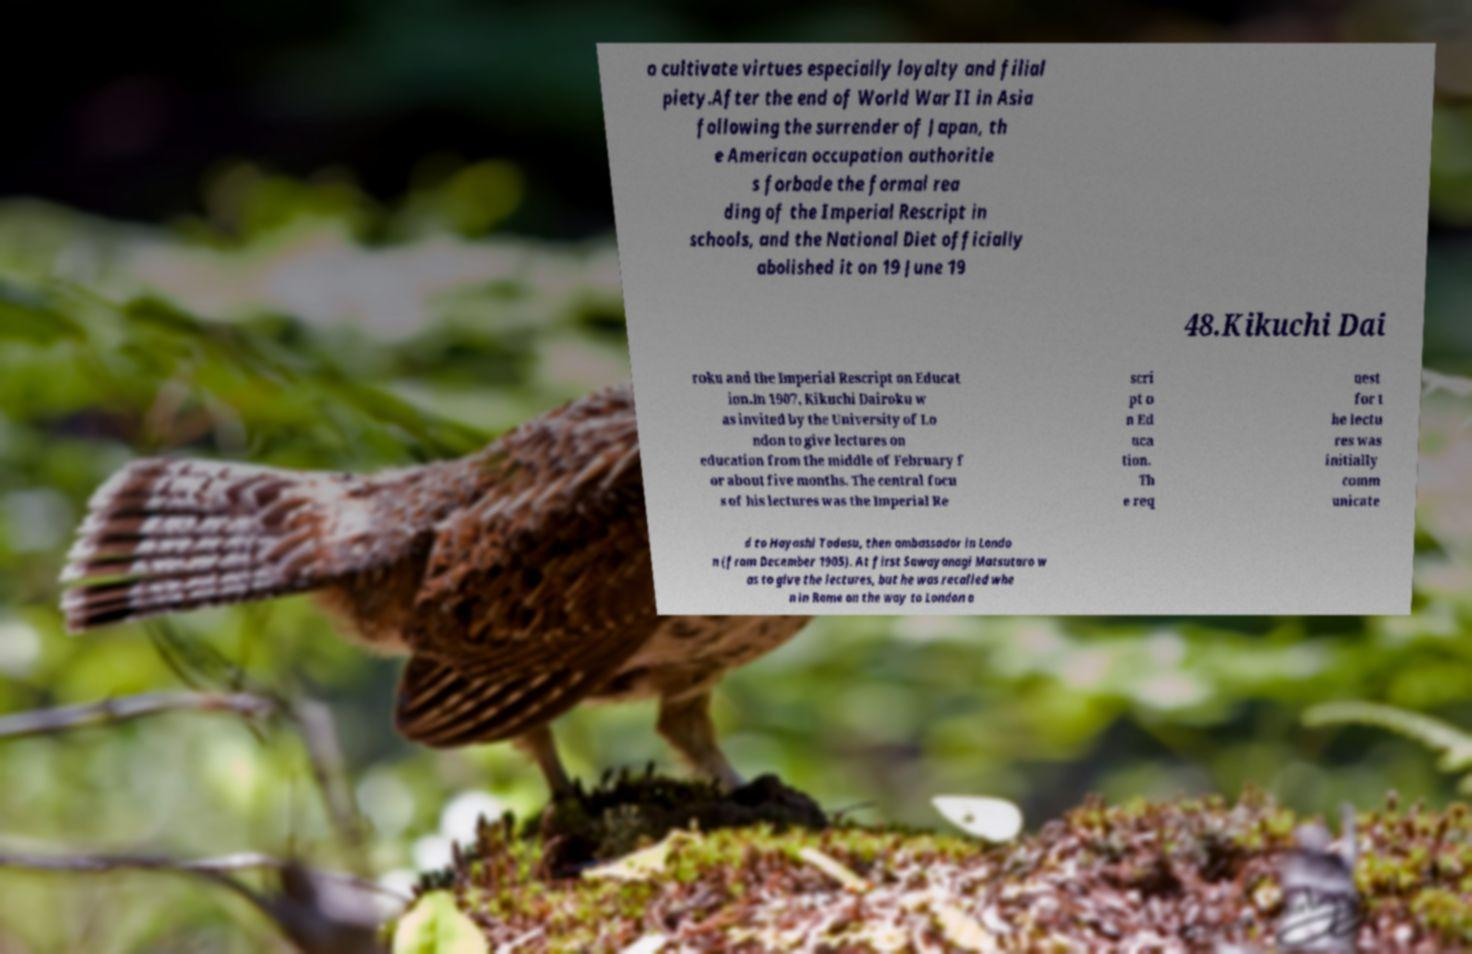Could you extract and type out the text from this image? o cultivate virtues especially loyalty and filial piety.After the end of World War II in Asia following the surrender of Japan, th e American occupation authoritie s forbade the formal rea ding of the Imperial Rescript in schools, and the National Diet officially abolished it on 19 June 19 48.Kikuchi Dai roku and the Imperial Rescript on Educat ion.In 1907, Kikuchi Dairoku w as invited by the University of Lo ndon to give lectures on education from the middle of February f or about five months. The central focu s of his lectures was the Imperial Re scri pt o n Ed uca tion. Th e req uest for t he lectu res was initially comm unicate d to Hayashi Tadasu, then ambassador in Londo n (from December 1905). At first Sawayanagi Matsutaro w as to give the lectures, but he was recalled whe n in Rome on the way to London a 